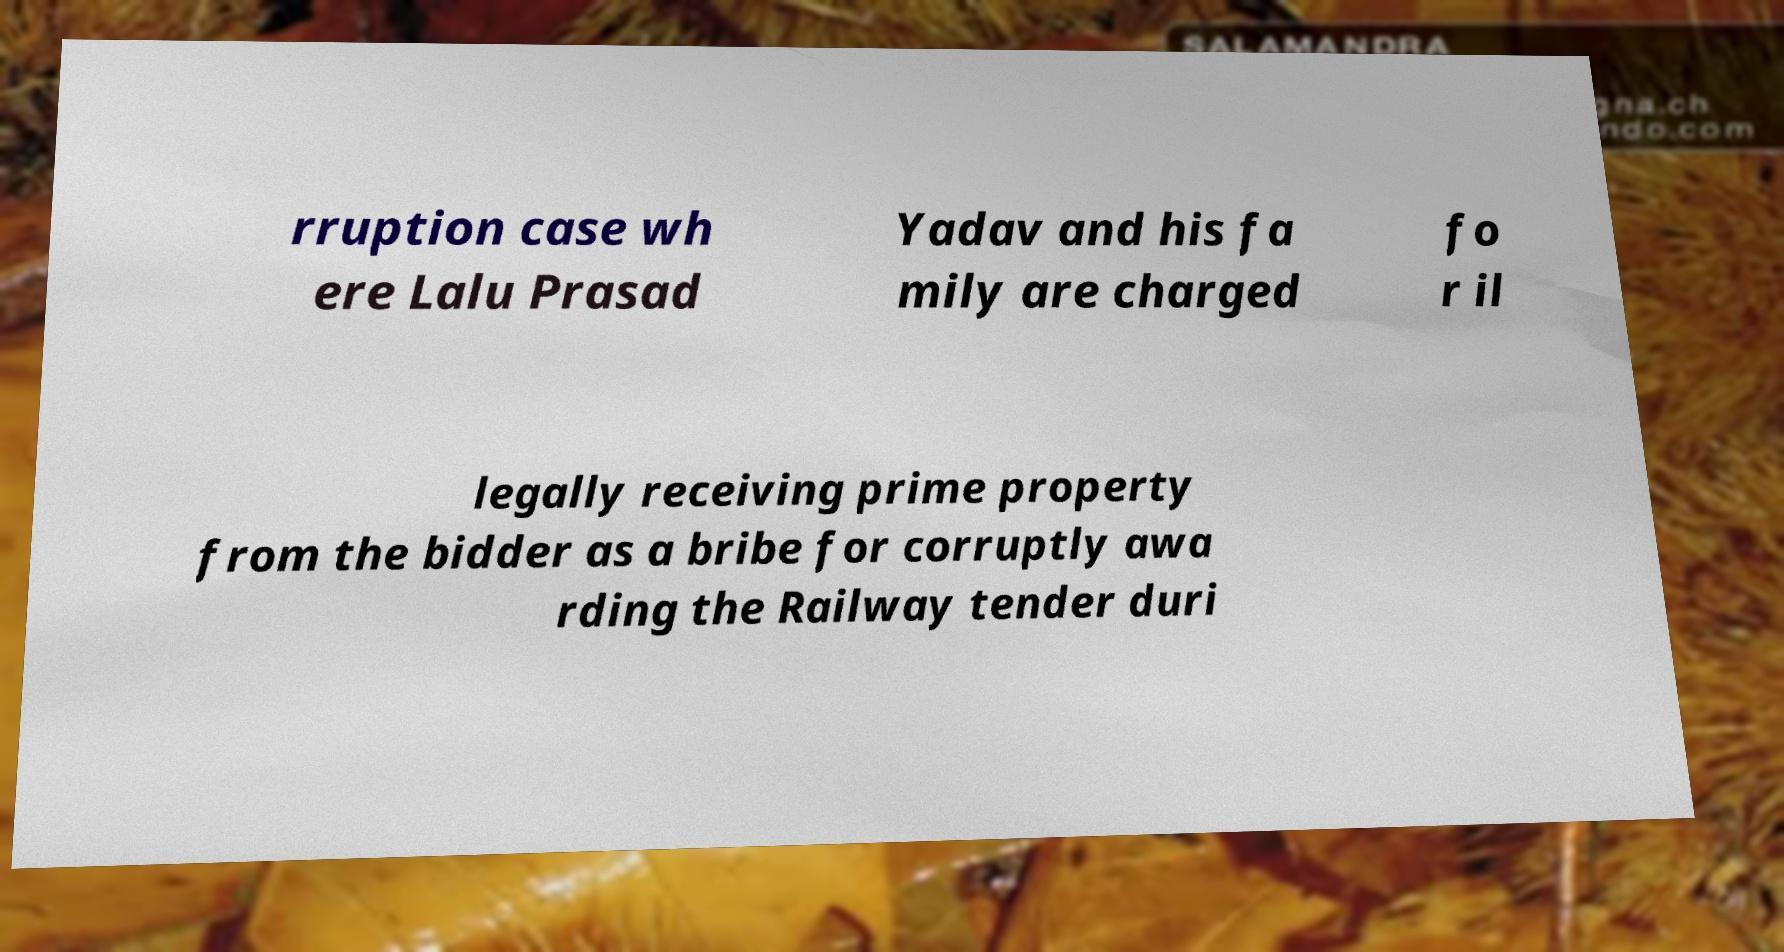What messages or text are displayed in this image? I need them in a readable, typed format. rruption case wh ere Lalu Prasad Yadav and his fa mily are charged fo r il legally receiving prime property from the bidder as a bribe for corruptly awa rding the Railway tender duri 